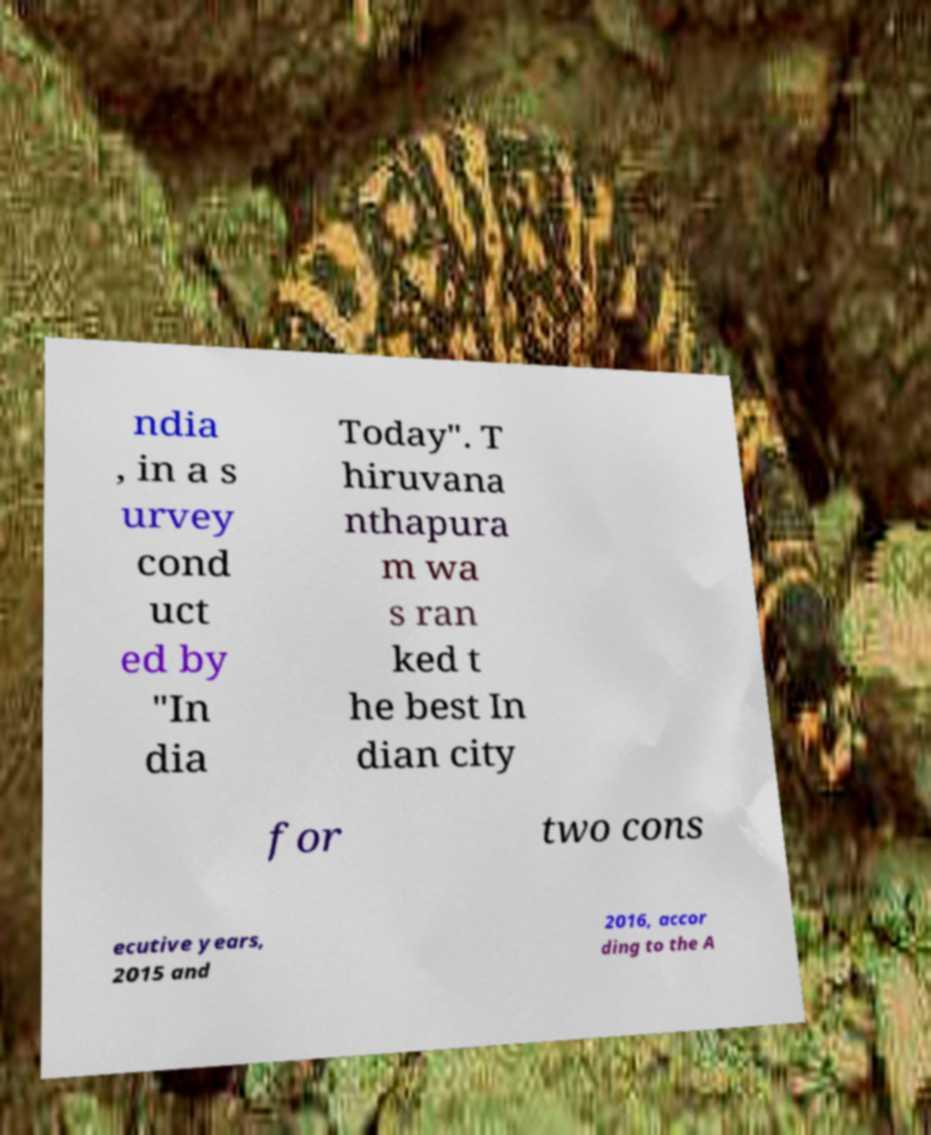Please read and relay the text visible in this image. What does it say? ndia , in a s urvey cond uct ed by "In dia Today". T hiruvana nthapura m wa s ran ked t he best In dian city for two cons ecutive years, 2015 and 2016, accor ding to the A 